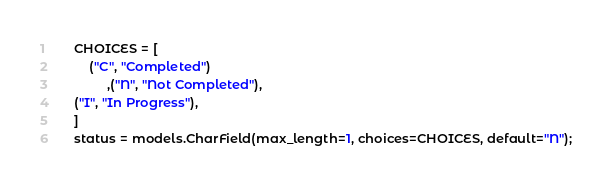<code> <loc_0><loc_0><loc_500><loc_500><_Python_>    CHOICES = [
        ("C", "Completed")
             ,("N", "Not Completed"),
    ("I", "In Progress"),
    ]
    status = models.CharField(max_length=1, choices=CHOICES, default="N");


</code> 